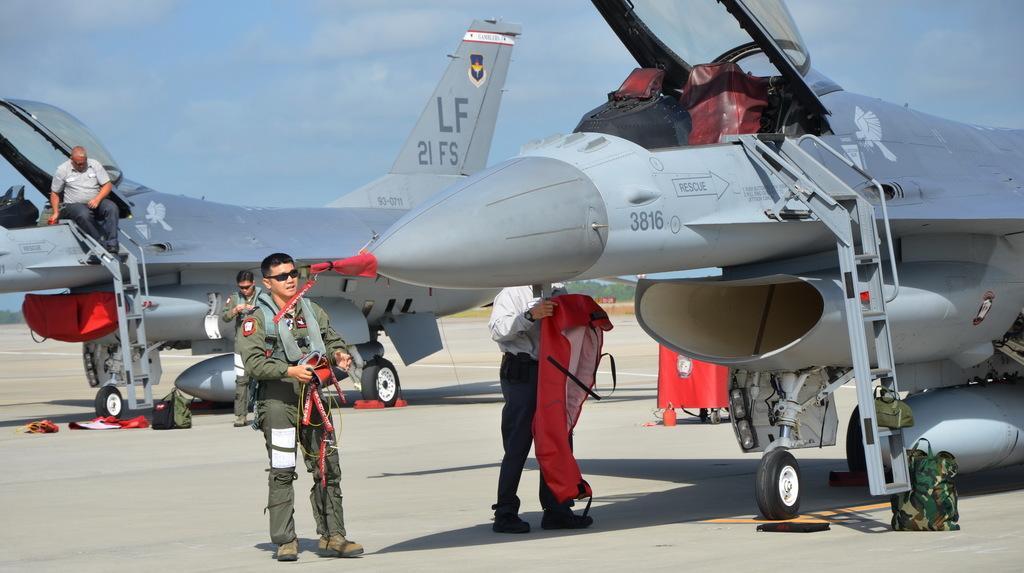Could you give a brief overview of what you see in this image? In the image there are two jets and on the second letter is a man sitting on a ladder and there are three men in between the two jets. 